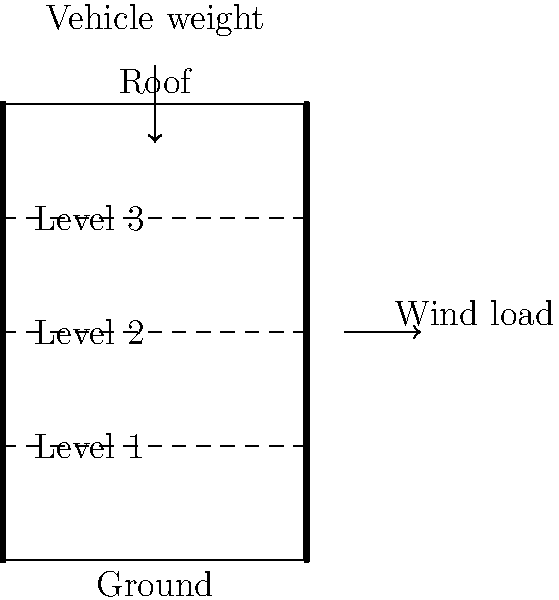As a frequent visitor to The Oracle shopping center, you've noticed the nearby multi-story car park. Given that Reading experiences average wind speeds of 10 mph and the car park can accommodate vehicles weighing up to 2.5 tons each, what is the primary structural consideration for ensuring the car park's integrity against lateral and vertical loads? To determine the primary structural consideration for the multi-story car park near The Oracle shopping center, we need to analyze both lateral (wind) and vertical (vehicle weight) loads:

1. Lateral load (wind):
   - Average wind speed in Reading: 10 mph ≈ 4.47 m/s
   - Wind pressure can be calculated using the formula: $P = \frac{1}{2} \rho v^2$
   where $\rho$ is air density (approximately 1.225 kg/m³) and $v$ is wind velocity.
   $P = \frac{1}{2} \times 1.225 \times 4.47^2 = 12.23$ Pa

2. Vertical load (vehicles):
   - Maximum vehicle weight: 2.5 tons = 2500 kg
   - Gravitational acceleration: $g = 9.81$ m/s²
   - Force exerted by each vehicle: $F = mg = 2500 \times 9.81 = 24,525$ N

3. Comparing loads:
   - The vertical load from vehicles is significantly higher than the lateral wind load.
   - However, wind load acts on the entire face of the building, while vehicle loads are distributed across floor areas.

4. Structural considerations:
   - Lateral stability: Shear walls or moment-resisting frames to resist wind loads
   - Vertical load-bearing: Columns and beams to transfer vehicle weights to the foundation
   - Floor system: Designed to distribute point loads from vehicles

5. Primary consideration:
   Given the significant vehicle weights and multi-story nature of the car park, the primary structural consideration would be the vertical load-bearing system. This system must efficiently transfer the substantial vehicle loads through the structure to the foundation while maintaining the integrity of each floor level.
Answer: Vertical load-bearing system 